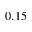Convert formula to latex. <formula><loc_0><loc_0><loc_500><loc_500>0 . 1 5</formula> 